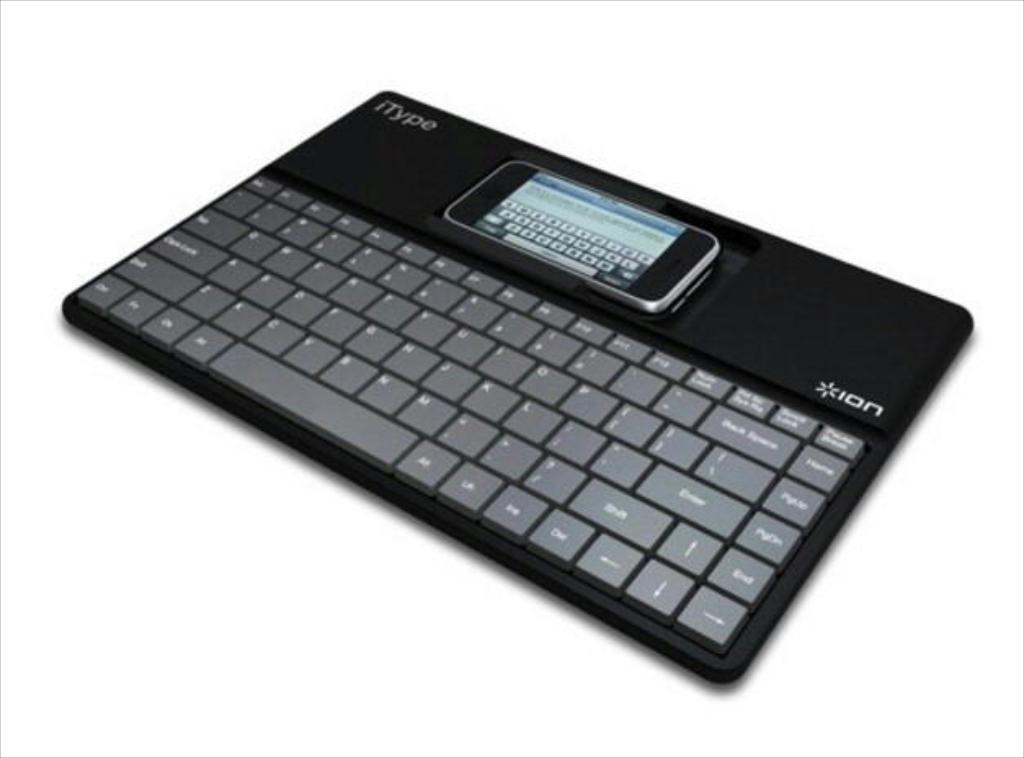What is the keyboard's brand?
Keep it short and to the point. Ion. Is there a "pagedown" key?
Your answer should be compact. Yes. 